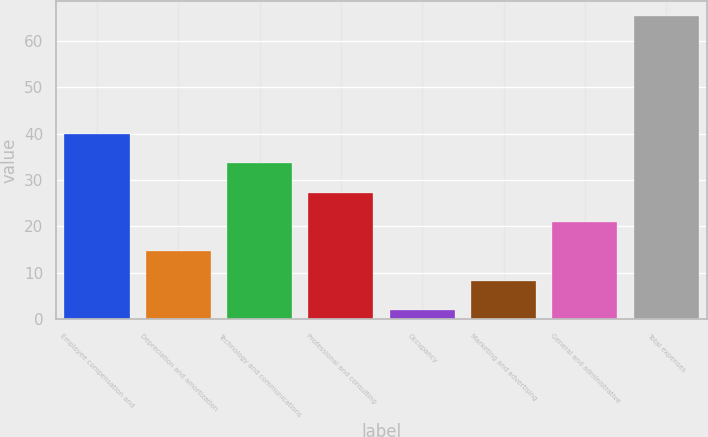<chart> <loc_0><loc_0><loc_500><loc_500><bar_chart><fcel>Employee compensation and<fcel>Depreciation and amortization<fcel>Technology and communications<fcel>Professional and consulting<fcel>Occupancy<fcel>Marketing and advertising<fcel>General and administrative<fcel>Total expenses<nl><fcel>39.92<fcel>14.64<fcel>33.6<fcel>27.28<fcel>2<fcel>8.32<fcel>20.96<fcel>65.2<nl></chart> 